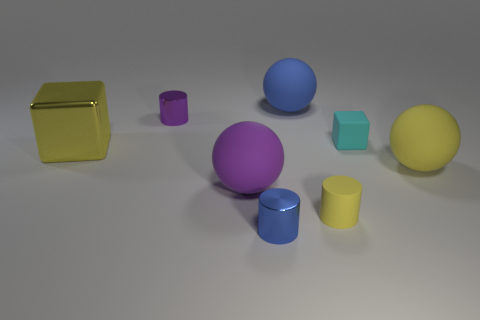What number of big matte spheres are the same color as the big cube?
Offer a very short reply. 1. What is the material of the yellow thing that is on the left side of the small purple cylinder?
Provide a short and direct response. Metal. What number of other objects are there of the same size as the blue sphere?
Your answer should be very brief. 3. How big is the sphere behind the metal block?
Offer a very short reply. Large. What material is the tiny object that is behind the tiny cyan object that is behind the big yellow object in front of the large yellow metal thing?
Provide a succinct answer. Metal. Does the big yellow metallic thing have the same shape as the cyan matte object?
Your response must be concise. Yes. How many rubber objects are either small things or tiny yellow cylinders?
Offer a terse response. 2. What number of small objects are there?
Give a very brief answer. 4. The rubber cylinder that is the same size as the blue metallic cylinder is what color?
Provide a succinct answer. Yellow. Is the purple shiny object the same size as the matte cylinder?
Make the answer very short. Yes. 